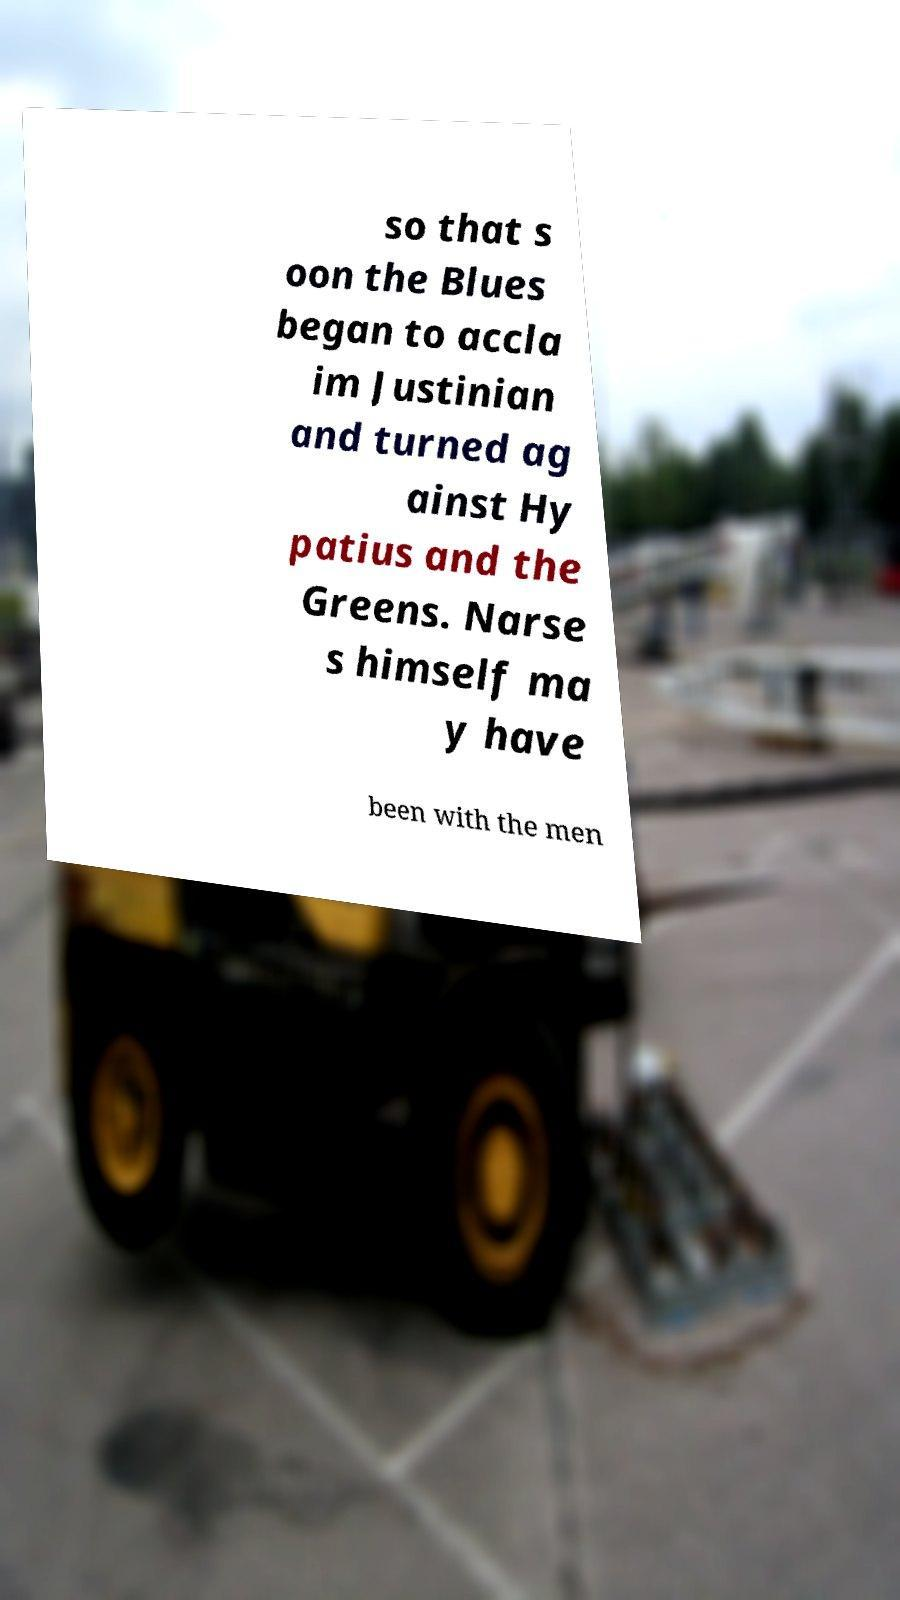Please identify and transcribe the text found in this image. so that s oon the Blues began to accla im Justinian and turned ag ainst Hy patius and the Greens. Narse s himself ma y have been with the men 